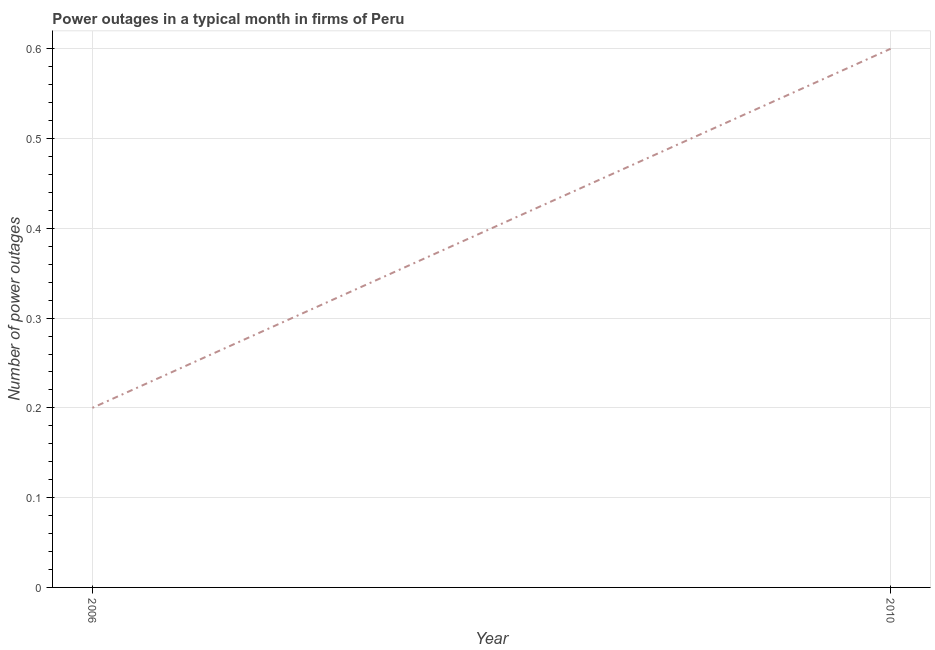What is the number of power outages in 2006?
Your answer should be compact. 0.2. Across all years, what is the maximum number of power outages?
Your response must be concise. 0.6. In which year was the number of power outages maximum?
Your response must be concise. 2010. In which year was the number of power outages minimum?
Provide a short and direct response. 2006. What is the difference between the number of power outages in 2006 and 2010?
Provide a short and direct response. -0.4. In how many years, is the number of power outages greater than 0.36000000000000004 ?
Provide a short and direct response. 1. What is the ratio of the number of power outages in 2006 to that in 2010?
Provide a succinct answer. 0.33. Is the number of power outages in 2006 less than that in 2010?
Your answer should be very brief. Yes. Does the number of power outages monotonically increase over the years?
Your answer should be compact. Yes. How many lines are there?
Your response must be concise. 1. How many years are there in the graph?
Provide a short and direct response. 2. What is the difference between two consecutive major ticks on the Y-axis?
Your answer should be very brief. 0.1. Are the values on the major ticks of Y-axis written in scientific E-notation?
Make the answer very short. No. What is the title of the graph?
Offer a very short reply. Power outages in a typical month in firms of Peru. What is the label or title of the X-axis?
Keep it short and to the point. Year. What is the label or title of the Y-axis?
Offer a very short reply. Number of power outages. What is the Number of power outages in 2010?
Provide a succinct answer. 0.6. What is the difference between the Number of power outages in 2006 and 2010?
Provide a short and direct response. -0.4. What is the ratio of the Number of power outages in 2006 to that in 2010?
Your answer should be compact. 0.33. 